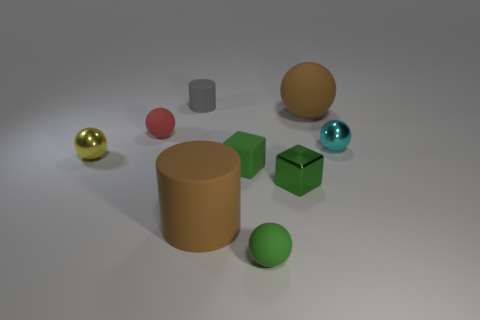Subtract all green spheres. How many spheres are left? 4 Subtract 1 balls. How many balls are left? 4 Subtract all small cyan spheres. How many spheres are left? 4 Subtract all blue spheres. Subtract all yellow blocks. How many spheres are left? 5 Add 1 tiny gray objects. How many objects exist? 10 Subtract all cubes. How many objects are left? 7 Add 3 large brown rubber cylinders. How many large brown rubber cylinders are left? 4 Add 7 tiny cyan things. How many tiny cyan things exist? 8 Subtract 0 yellow cubes. How many objects are left? 9 Subtract all small shiny balls. Subtract all tiny green matte cubes. How many objects are left? 6 